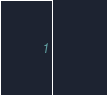<code> <loc_0><loc_0><loc_500><loc_500><_SQL_>    </code> 